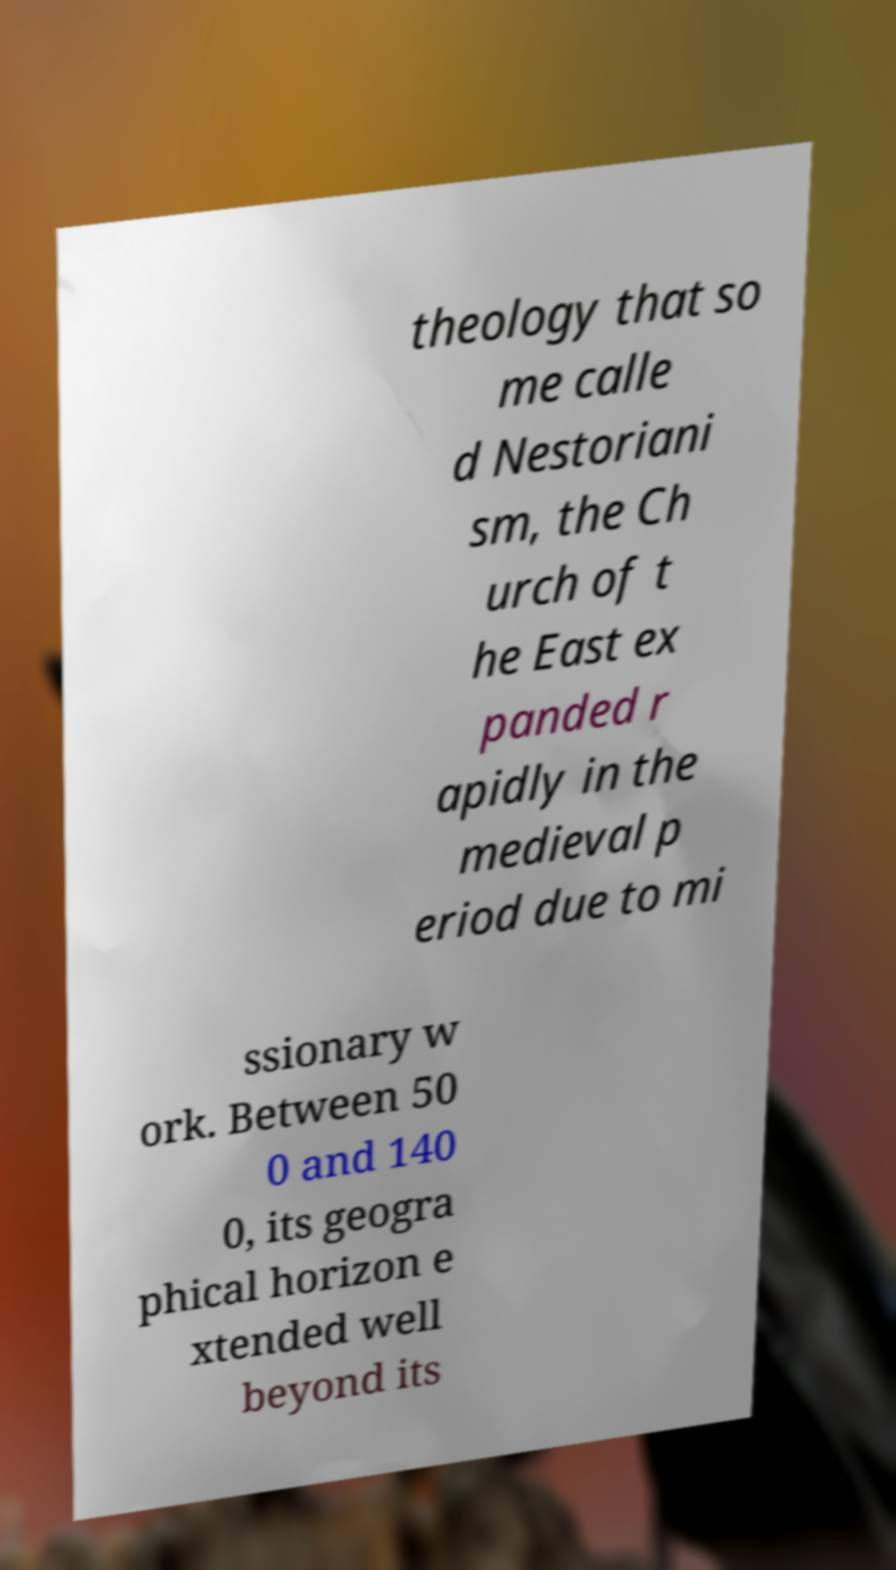For documentation purposes, I need the text within this image transcribed. Could you provide that? theology that so me calle d Nestoriani sm, the Ch urch of t he East ex panded r apidly in the medieval p eriod due to mi ssionary w ork. Between 50 0 and 140 0, its geogra phical horizon e xtended well beyond its 